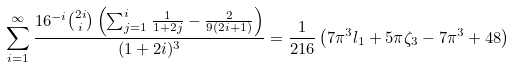Convert formula to latex. <formula><loc_0><loc_0><loc_500><loc_500>\sum _ { i = 1 } ^ { \infty } \frac { 1 6 ^ { - i } \binom { 2 i } { i } \left ( \sum _ { j = 1 } ^ { i } \frac { 1 } { 1 + 2 j } - \frac { 2 } { 9 ( 2 i + 1 ) } \right ) } { ( 1 + 2 i ) ^ { 3 } } = \frac { 1 } { 2 1 6 } \left ( 7 \pi ^ { 3 } l _ { 1 } + 5 \pi \zeta _ { 3 } - 7 \pi ^ { 3 } + 4 8 \right )</formula> 